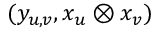<formula> <loc_0><loc_0><loc_500><loc_500>( y _ { u , v } , x _ { u } \otimes x _ { v } )</formula> 